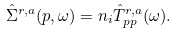<formula> <loc_0><loc_0><loc_500><loc_500>\hat { \Sigma } ^ { r , a } ( { p } , \omega ) = n _ { i } \hat { T } ^ { r , a } _ { p p } ( \omega ) .</formula> 